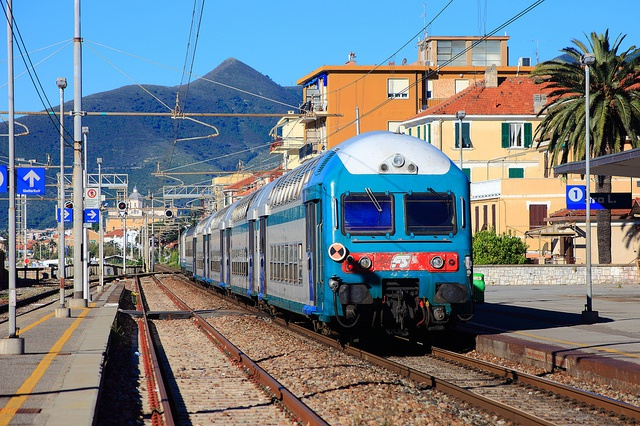Describe the objects in this image and their specific colors. I can see a train in navy, black, darkgray, lightblue, and lightgray tones in this image. 